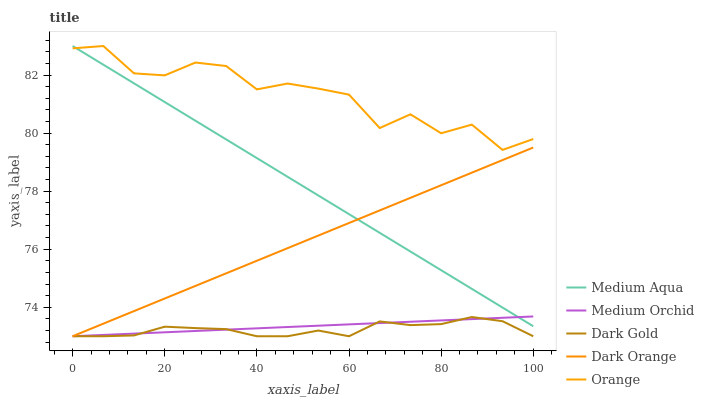Does Dark Gold have the minimum area under the curve?
Answer yes or no. Yes. Does Orange have the maximum area under the curve?
Answer yes or no. Yes. Does Dark Orange have the minimum area under the curve?
Answer yes or no. No. Does Dark Orange have the maximum area under the curve?
Answer yes or no. No. Is Medium Orchid the smoothest?
Answer yes or no. Yes. Is Orange the roughest?
Answer yes or no. Yes. Is Dark Orange the smoothest?
Answer yes or no. No. Is Dark Orange the roughest?
Answer yes or no. No. Does Medium Aqua have the lowest value?
Answer yes or no. No. Does Dark Orange have the highest value?
Answer yes or no. No. Is Medium Orchid less than Orange?
Answer yes or no. Yes. Is Medium Aqua greater than Dark Gold?
Answer yes or no. Yes. Does Medium Orchid intersect Orange?
Answer yes or no. No. 